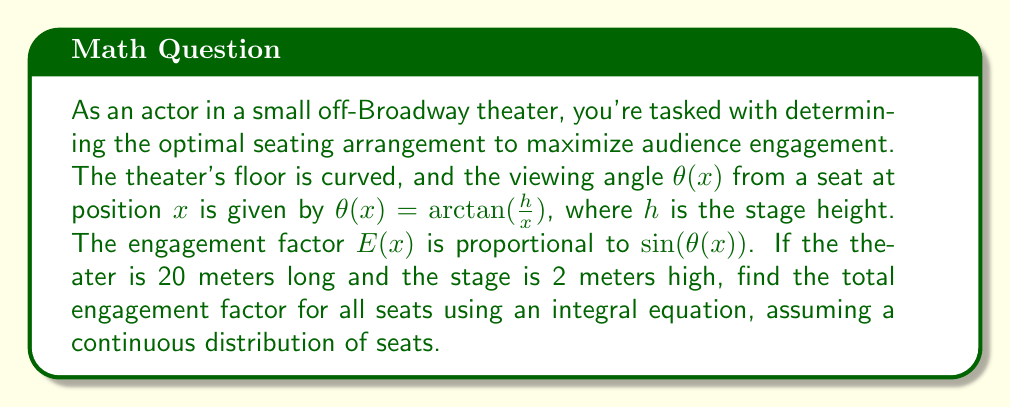Teach me how to tackle this problem. Let's approach this step-by-step:

1) The viewing angle $\theta(x)$ is given by:
   $$\theta(x) = \arctan(\frac{h}{x})$$

2) The engagement factor $E(x)$ is proportional to $\sin(\theta(x))$:
   $$E(x) \propto \sin(\theta(x)) = \sin(\arctan(\frac{h}{x}))$$

3) We know that $\sin(\arctan(y)) = \frac{y}{\sqrt{1+y^2}}$, so:
   $$E(x) = \frac{h/x}{\sqrt{1+(h/x)^2}} = \frac{h}{\sqrt{x^2+h^2}}$$

4) To find the total engagement factor, we need to integrate $E(x)$ over the length of the theater:
   $$\text{Total Engagement} = \int_0^{20} E(x) dx = \int_0^{20} \frac{h}{\sqrt{x^2+h^2}} dx$$

5) Given $h = 2$ meters, our integral becomes:
   $$\text{Total Engagement} = \int_0^{20} \frac{2}{\sqrt{x^2+4}} dx$$

6) This integral can be solved using the substitution $x = 2\sinh(u)$:
   $$\text{Total Engagement} = 2 \int_0^{\sinh^{-1}(10)} du = 2\sinh^{-1}(10)$$

7) The value of $\sinh^{-1}(10)$ is approximately 2.99822.

8) Therefore, the total engagement factor is approximately:
   $$\text{Total Engagement} \approx 2 * 2.99822 = 5.99644$$
Answer: $5.99644$ 